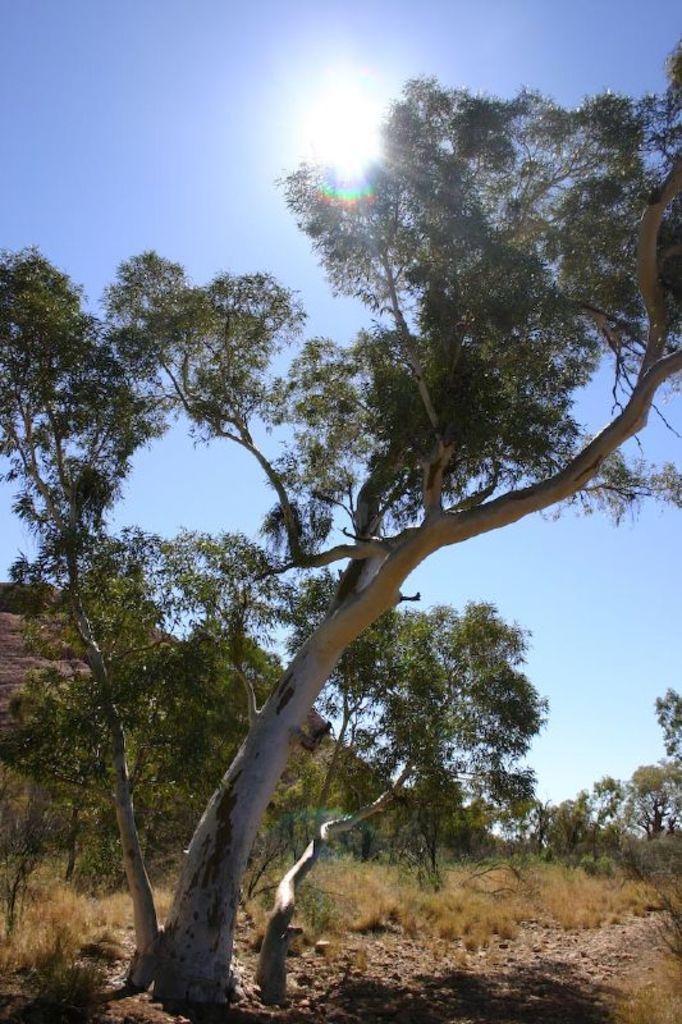Describe this image in one or two sentences. In this image we can see the mountain, some rocks on the ground, some dried leaves on the ground, some trees, bushes, plants and grass on the ground. At the top there is the sun in the sky. 